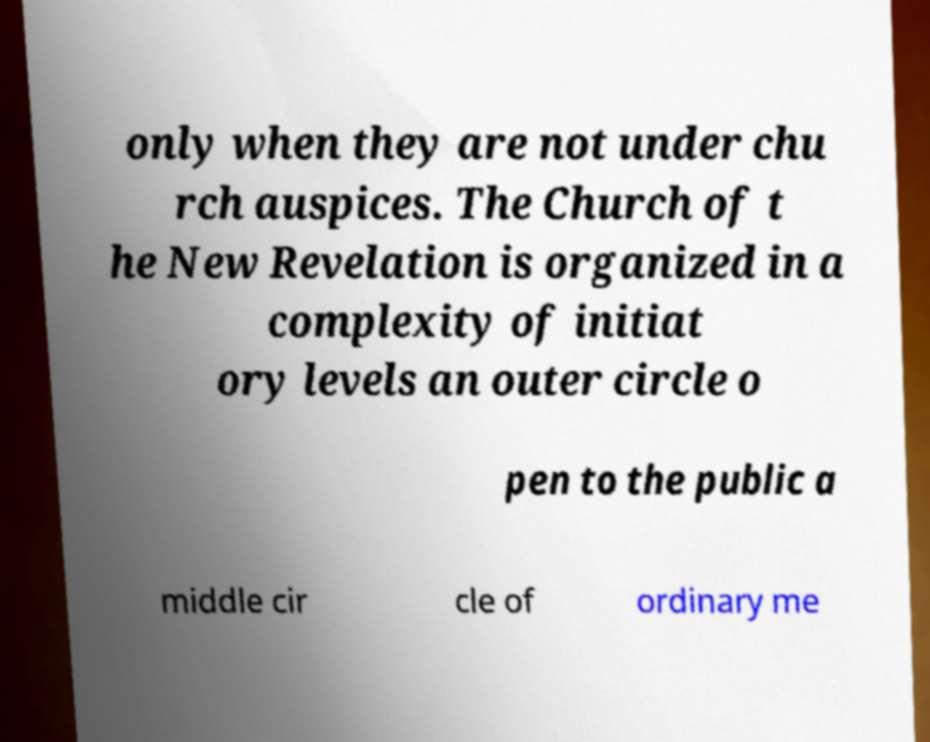For documentation purposes, I need the text within this image transcribed. Could you provide that? only when they are not under chu rch auspices. The Church of t he New Revelation is organized in a complexity of initiat ory levels an outer circle o pen to the public a middle cir cle of ordinary me 